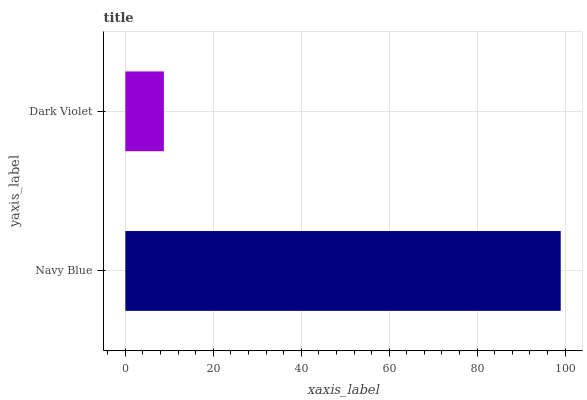Is Dark Violet the minimum?
Answer yes or no. Yes. Is Navy Blue the maximum?
Answer yes or no. Yes. Is Dark Violet the maximum?
Answer yes or no. No. Is Navy Blue greater than Dark Violet?
Answer yes or no. Yes. Is Dark Violet less than Navy Blue?
Answer yes or no. Yes. Is Dark Violet greater than Navy Blue?
Answer yes or no. No. Is Navy Blue less than Dark Violet?
Answer yes or no. No. Is Navy Blue the high median?
Answer yes or no. Yes. Is Dark Violet the low median?
Answer yes or no. Yes. Is Dark Violet the high median?
Answer yes or no. No. Is Navy Blue the low median?
Answer yes or no. No. 